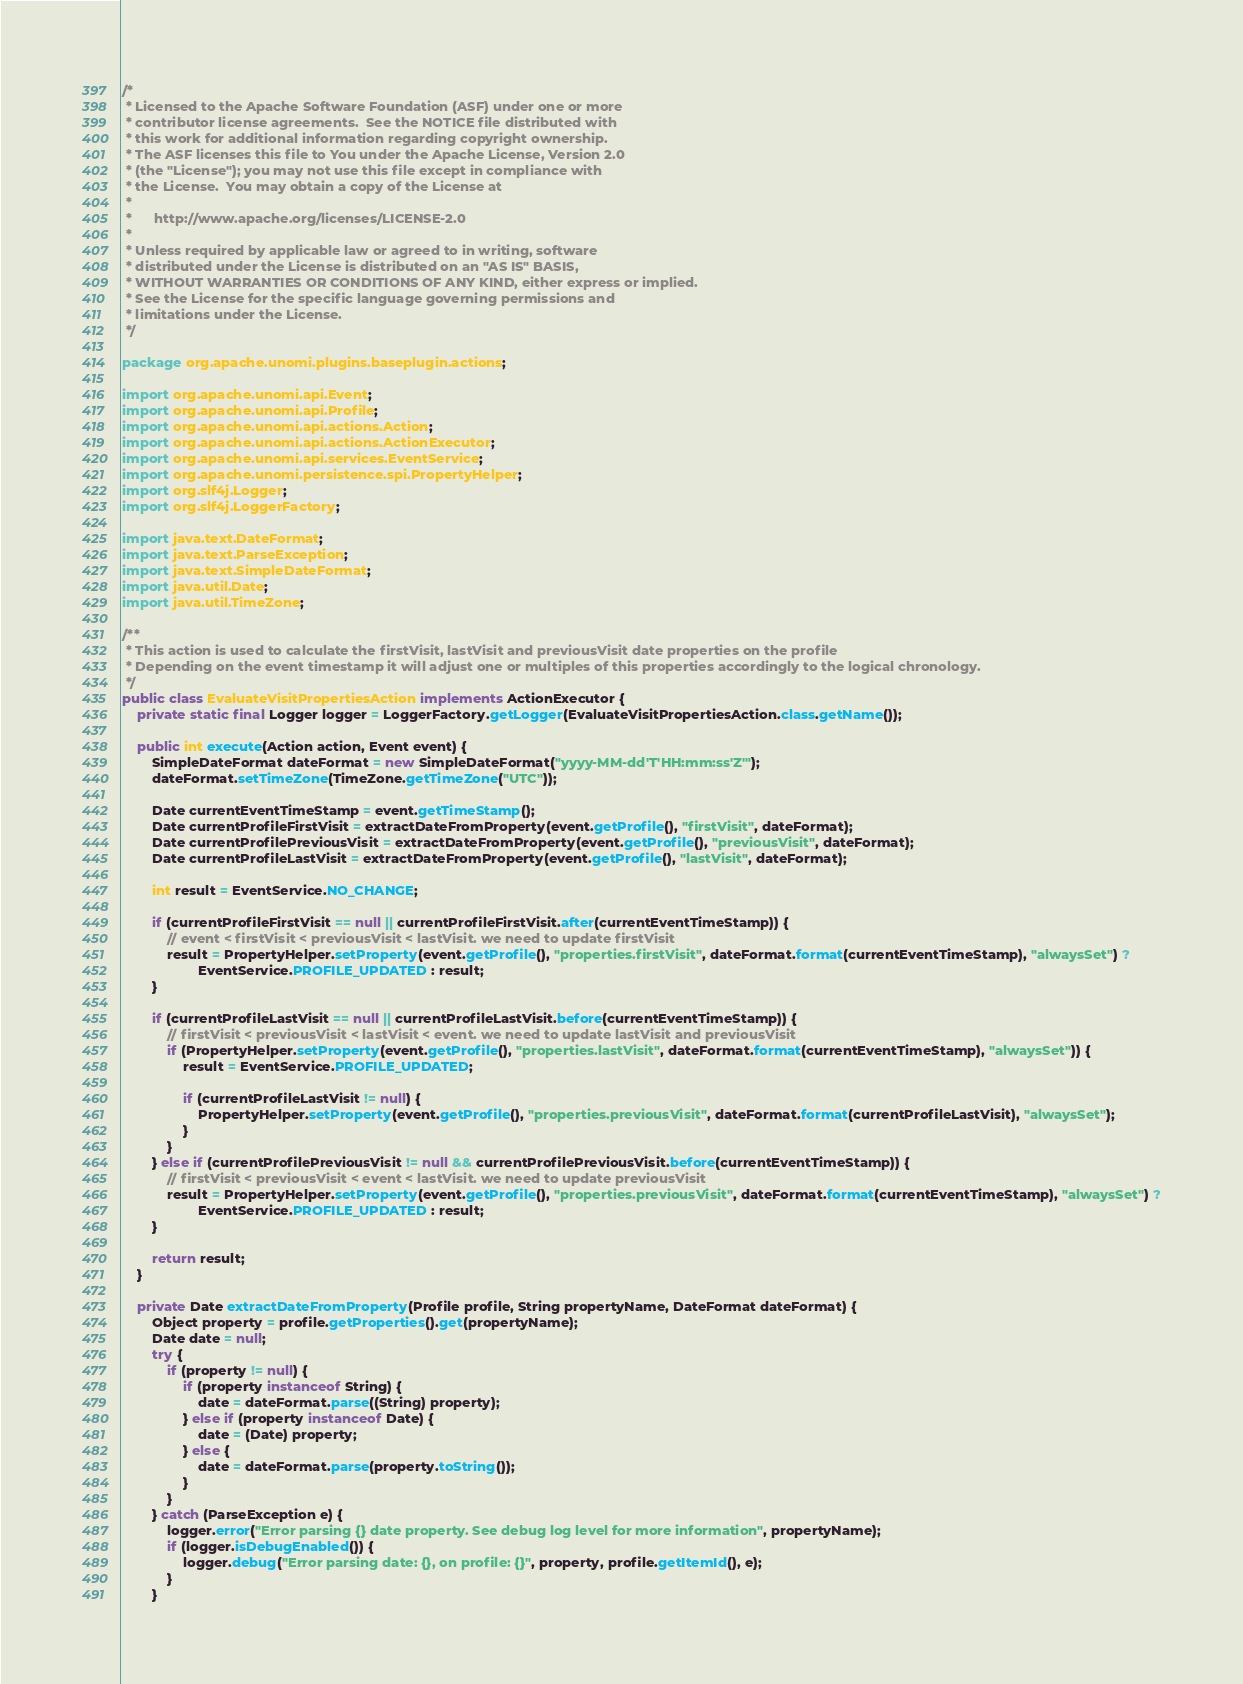Convert code to text. <code><loc_0><loc_0><loc_500><loc_500><_Java_>/*
 * Licensed to the Apache Software Foundation (ASF) under one or more
 * contributor license agreements.  See the NOTICE file distributed with
 * this work for additional information regarding copyright ownership.
 * The ASF licenses this file to You under the Apache License, Version 2.0
 * (the "License"); you may not use this file except in compliance with
 * the License.  You may obtain a copy of the License at
 *
 *      http://www.apache.org/licenses/LICENSE-2.0
 *
 * Unless required by applicable law or agreed to in writing, software
 * distributed under the License is distributed on an "AS IS" BASIS,
 * WITHOUT WARRANTIES OR CONDITIONS OF ANY KIND, either express or implied.
 * See the License for the specific language governing permissions and
 * limitations under the License.
 */

package org.apache.unomi.plugins.baseplugin.actions;

import org.apache.unomi.api.Event;
import org.apache.unomi.api.Profile;
import org.apache.unomi.api.actions.Action;
import org.apache.unomi.api.actions.ActionExecutor;
import org.apache.unomi.api.services.EventService;
import org.apache.unomi.persistence.spi.PropertyHelper;
import org.slf4j.Logger;
import org.slf4j.LoggerFactory;

import java.text.DateFormat;
import java.text.ParseException;
import java.text.SimpleDateFormat;
import java.util.Date;
import java.util.TimeZone;

/**
 * This action is used to calculate the firstVisit, lastVisit and previousVisit date properties on the profile
 * Depending on the event timestamp it will adjust one or multiples of this properties accordingly to the logical chronology.
 */
public class EvaluateVisitPropertiesAction implements ActionExecutor {
    private static final Logger logger = LoggerFactory.getLogger(EvaluateVisitPropertiesAction.class.getName());

    public int execute(Action action, Event event) {
        SimpleDateFormat dateFormat = new SimpleDateFormat("yyyy-MM-dd'T'HH:mm:ss'Z'");
        dateFormat.setTimeZone(TimeZone.getTimeZone("UTC"));

        Date currentEventTimeStamp = event.getTimeStamp();
        Date currentProfileFirstVisit = extractDateFromProperty(event.getProfile(), "firstVisit", dateFormat);
        Date currentProfilePreviousVisit = extractDateFromProperty(event.getProfile(), "previousVisit", dateFormat);
        Date currentProfileLastVisit = extractDateFromProperty(event.getProfile(), "lastVisit", dateFormat);

        int result = EventService.NO_CHANGE;

        if (currentProfileFirstVisit == null || currentProfileFirstVisit.after(currentEventTimeStamp)) {
            // event < firstVisit < previousVisit < lastVisit. we need to update firstVisit
            result = PropertyHelper.setProperty(event.getProfile(), "properties.firstVisit", dateFormat.format(currentEventTimeStamp), "alwaysSet") ?
                    EventService.PROFILE_UPDATED : result;
        }

        if (currentProfileLastVisit == null || currentProfileLastVisit.before(currentEventTimeStamp)) {
            // firstVisit < previousVisit < lastVisit < event. we need to update lastVisit and previousVisit
            if (PropertyHelper.setProperty(event.getProfile(), "properties.lastVisit", dateFormat.format(currentEventTimeStamp), "alwaysSet")) {
                result = EventService.PROFILE_UPDATED;

                if (currentProfileLastVisit != null) {
                    PropertyHelper.setProperty(event.getProfile(), "properties.previousVisit", dateFormat.format(currentProfileLastVisit), "alwaysSet");
                }
            }
        } else if (currentProfilePreviousVisit != null && currentProfilePreviousVisit.before(currentEventTimeStamp)) {
            // firstVisit < previousVisit < event < lastVisit. we need to update previousVisit
            result = PropertyHelper.setProperty(event.getProfile(), "properties.previousVisit", dateFormat.format(currentEventTimeStamp), "alwaysSet") ?
                    EventService.PROFILE_UPDATED : result;
        }

        return result;
    }

    private Date extractDateFromProperty(Profile profile, String propertyName, DateFormat dateFormat) {
        Object property = profile.getProperties().get(propertyName);
        Date date = null;
        try {
            if (property != null) {
                if (property instanceof String) {
                    date = dateFormat.parse((String) property);
                } else if (property instanceof Date) {
                    date = (Date) property;
                } else {
                    date = dateFormat.parse(property.toString());
                }
            }
        } catch (ParseException e) {
            logger.error("Error parsing {} date property. See debug log level for more information", propertyName);
            if (logger.isDebugEnabled()) {
                logger.debug("Error parsing date: {}, on profile: {}", property, profile.getItemId(), e);
            }
        }
</code> 